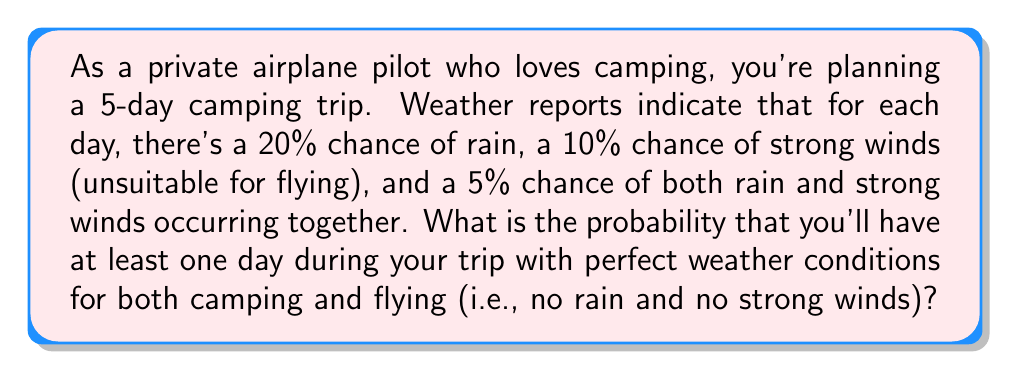Give your solution to this math problem. Let's approach this step-by-step:

1) First, let's calculate the probability of a single day having perfect weather conditions.

   P(perfect day) = 1 - P(rain or strong winds)
   
   We can use the addition rule of probability:
   P(A or B) = P(A) + P(B) - P(A and B)

   P(rain or strong winds) = 0.20 + 0.10 - 0.05 = 0.25
   
   So, P(perfect day) = 1 - 0.25 = 0.75 or 75%

2) Now, we need to find the probability of having at least one perfect day out of 5 days.

3) It's easier to calculate the probability of not having any perfect days and then subtract that from 1.

4) The probability of not having a perfect day is 1 - 0.75 = 0.25 or 25%

5) For all 5 days to not be perfect, we multiply this probability by itself 5 times:

   P(no perfect days) = $0.25^5 = 0.0009765625$

6) Therefore, the probability of having at least one perfect day is:

   P(at least one perfect day) = 1 - P(no perfect days)
                                = $1 - 0.0009765625$
                                = $0.9990234375$

7) Convert to a percentage:
   $0.9990234375 * 100 = 99.90234375\%$
Answer: The probability of having at least one day with perfect weather conditions for both camping and flying during the 5-day trip is approximately 99.90%. 